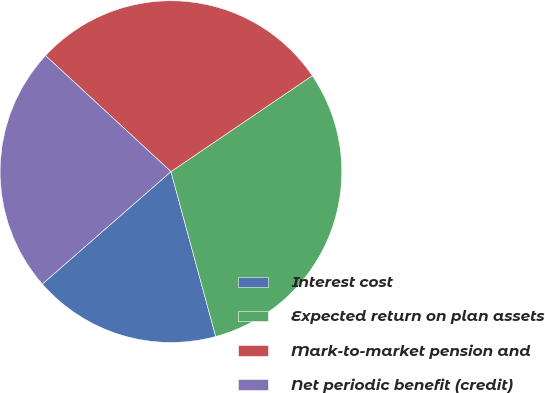Convert chart. <chart><loc_0><loc_0><loc_500><loc_500><pie_chart><fcel>Interest cost<fcel>Expected return on plan assets<fcel>Mark-to-market pension and<fcel>Net periodic benefit (credit)<nl><fcel>17.79%<fcel>30.27%<fcel>28.63%<fcel>23.31%<nl></chart> 